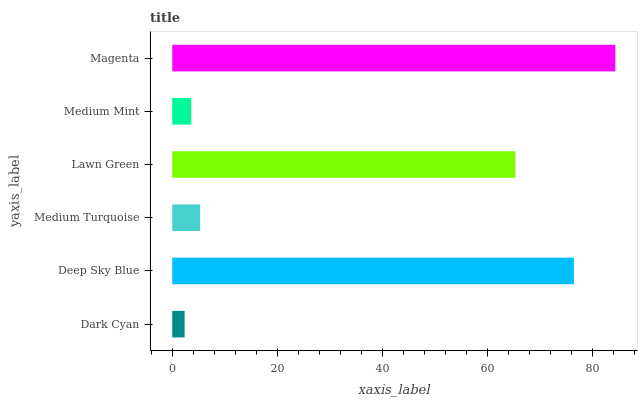Is Dark Cyan the minimum?
Answer yes or no. Yes. Is Magenta the maximum?
Answer yes or no. Yes. Is Deep Sky Blue the minimum?
Answer yes or no. No. Is Deep Sky Blue the maximum?
Answer yes or no. No. Is Deep Sky Blue greater than Dark Cyan?
Answer yes or no. Yes. Is Dark Cyan less than Deep Sky Blue?
Answer yes or no. Yes. Is Dark Cyan greater than Deep Sky Blue?
Answer yes or no. No. Is Deep Sky Blue less than Dark Cyan?
Answer yes or no. No. Is Lawn Green the high median?
Answer yes or no. Yes. Is Medium Turquoise the low median?
Answer yes or no. Yes. Is Magenta the high median?
Answer yes or no. No. Is Magenta the low median?
Answer yes or no. No. 